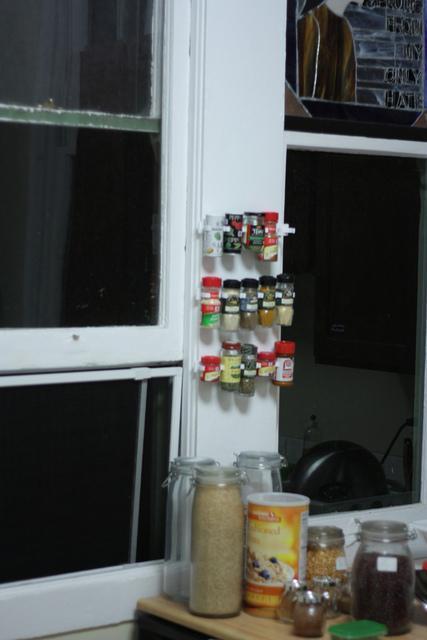How many jars are there?
Give a very brief answer. 5. How many windows do you see?
Give a very brief answer. 2. How many bottles can you see?
Give a very brief answer. 4. How many pieces of fruit in the bowl are green?
Give a very brief answer. 0. 